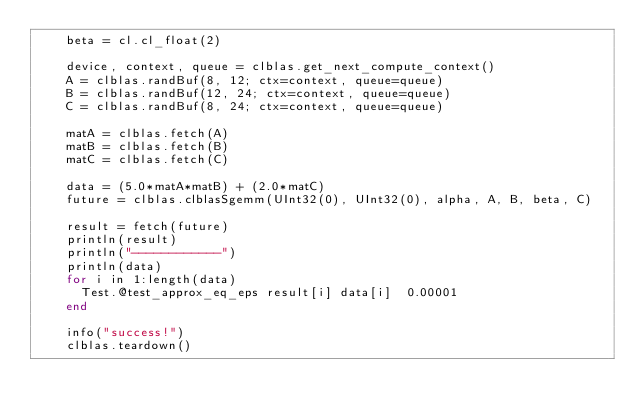<code> <loc_0><loc_0><loc_500><loc_500><_Julia_>    beta = cl.cl_float(2)

    device, context, queue = clblas.get_next_compute_context()
    A = clblas.randBuf(8, 12; ctx=context, queue=queue)
    B = clblas.randBuf(12, 24; ctx=context, queue=queue)
    C = clblas.randBuf(8, 24; ctx=context, queue=queue)

    matA = clblas.fetch(A)
    matB = clblas.fetch(B)
    matC = clblas.fetch(C)

    data = (5.0*matA*matB) + (2.0*matC)
    future = clblas.clblasSgemm(UInt32(0), UInt32(0), alpha, A, B, beta, C)

    result = fetch(future)
    println(result)
    println("------------")
    println(data)
    for i in 1:length(data)
      Test.@test_approx_eq_eps result[i] data[i]  0.00001
    end

    info("success!")
    clblas.teardown()
</code> 